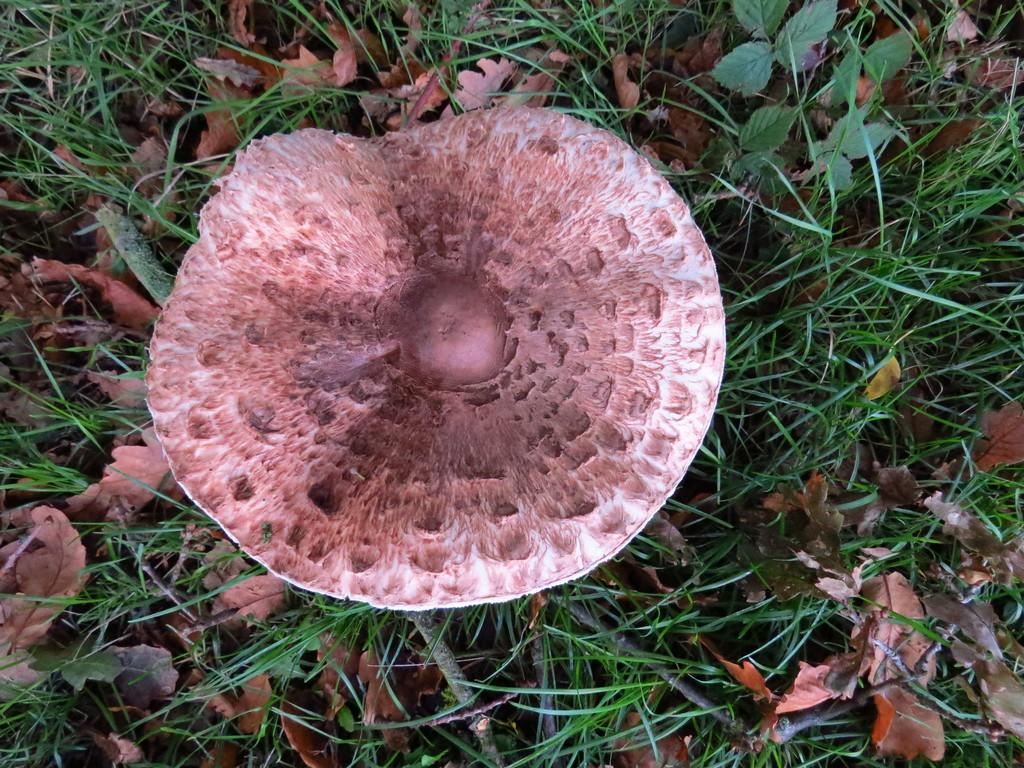What type of plant can be seen in the image? There is a mushroom in the image. What type of vegetation is present in the image? There is grass in the image. What can be found on the path in the image? There are dry leaves on the path in the image. What type of pets can be seen playing with the mushroom in the image? There are no pets present in the image, and the mushroom is not being played with. 